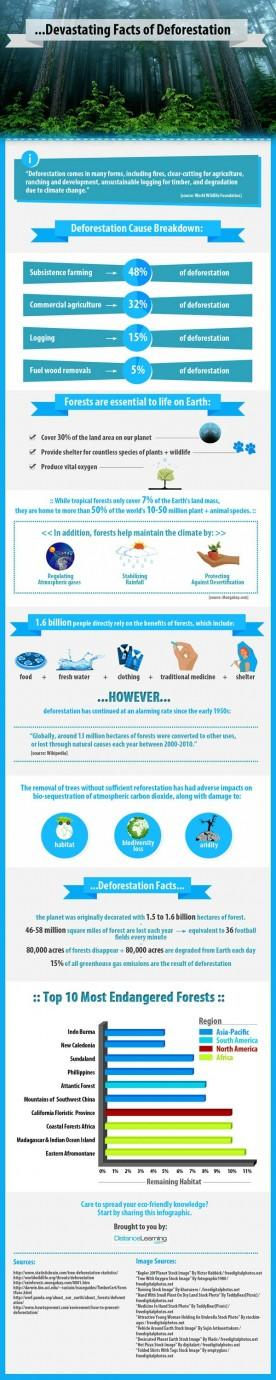Mention a couple of crucial points in this snapshot. The region with the most endangered forests is the Asia-Pacific. The Eastern African montane forest has close to 11% of the remaining habitat in Africa, making it a vital ecosystem for the preservation of diverse flora and fauna. 